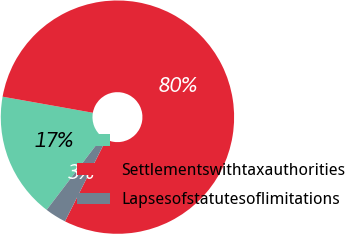Convert chart to OTSL. <chart><loc_0><loc_0><loc_500><loc_500><pie_chart><ecel><fcel>Settlementswithtaxauthorities<fcel>Lapsesofstatutesoflimitations<nl><fcel>17.43%<fcel>79.62%<fcel>2.95%<nl></chart> 